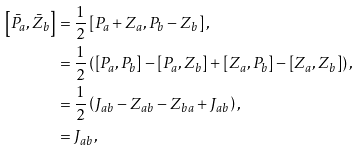<formula> <loc_0><loc_0><loc_500><loc_500>\left [ \bar { P } _ { a } , \bar { Z } _ { b } \right ] & = \frac { 1 } { 2 } \left [ P _ { a } + Z _ { a } , P _ { b } - Z _ { b } \right ] , \\ & = \frac { 1 } { 2 } \left ( \left [ P _ { a } , P _ { b } \right ] - \left [ P _ { a } , Z _ { b } \right ] + \left [ Z _ { a } , P _ { b } \right ] - \left [ Z _ { a } , Z _ { b } \right ] \right ) , \\ & = \frac { 1 } { 2 } \left ( J _ { a b } - Z _ { a b } - Z _ { b a } + J _ { a b } \right ) , \\ & = J _ { a b } ,</formula> 